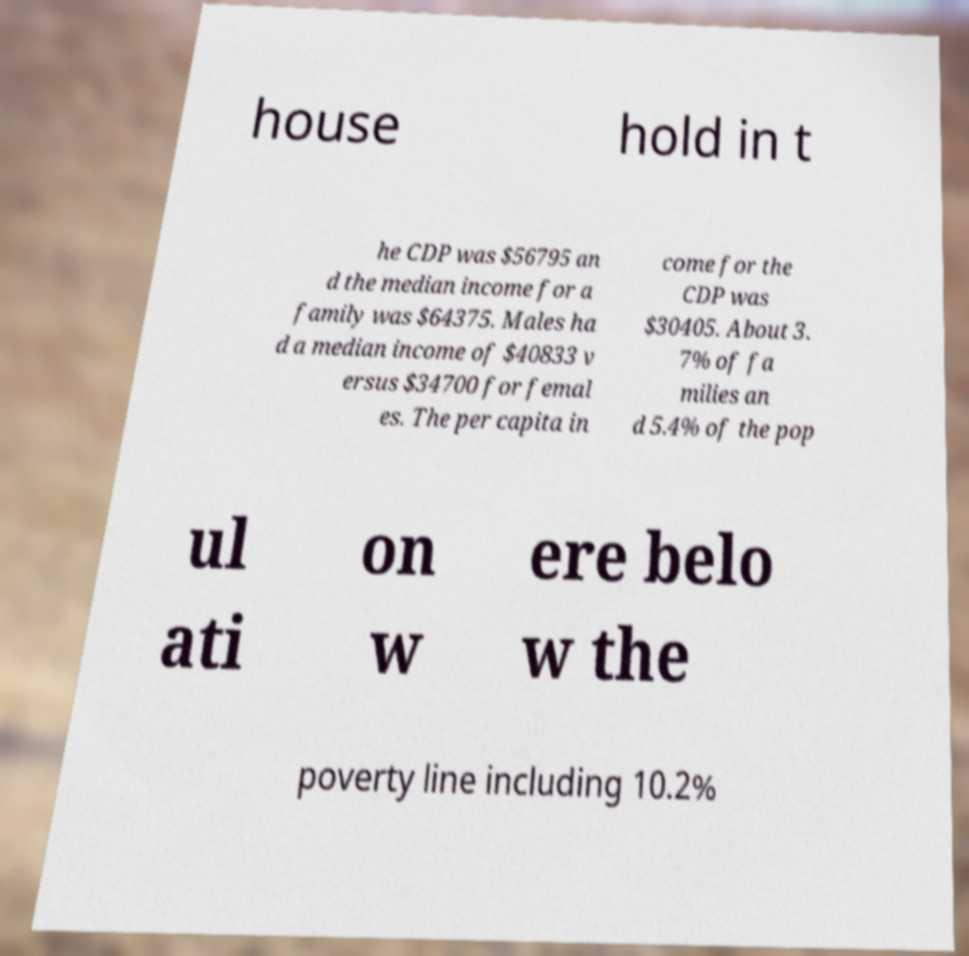Can you read and provide the text displayed in the image?This photo seems to have some interesting text. Can you extract and type it out for me? house hold in t he CDP was $56795 an d the median income for a family was $64375. Males ha d a median income of $40833 v ersus $34700 for femal es. The per capita in come for the CDP was $30405. About 3. 7% of fa milies an d 5.4% of the pop ul ati on w ere belo w the poverty line including 10.2% 